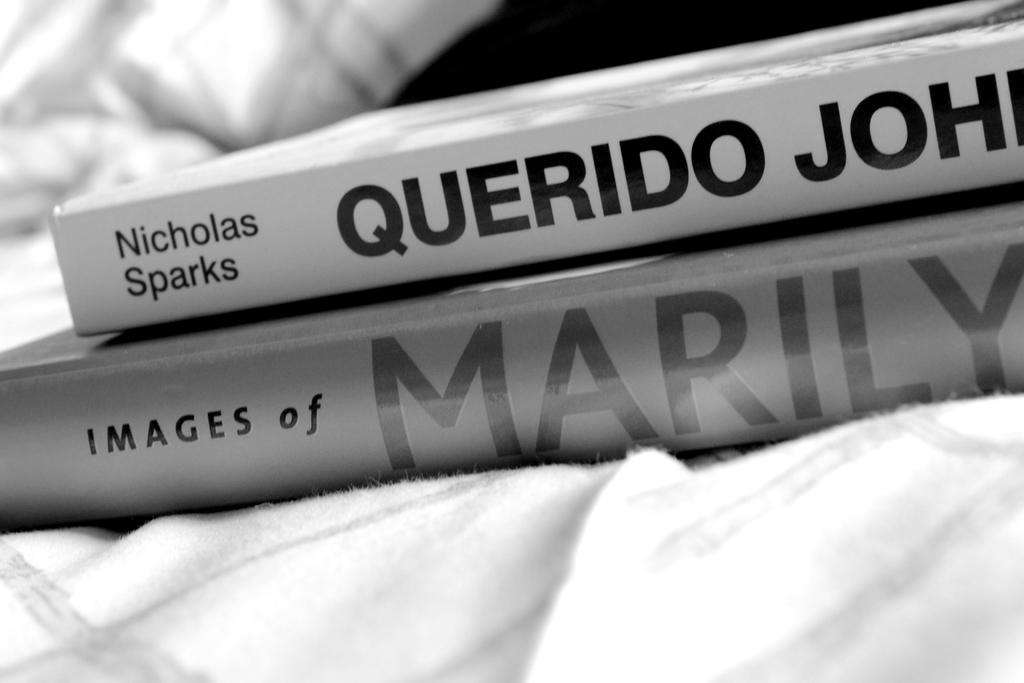<image>
Render a clear and concise summary of the photo. Two books stacked including one by Nicholas Sparks. 